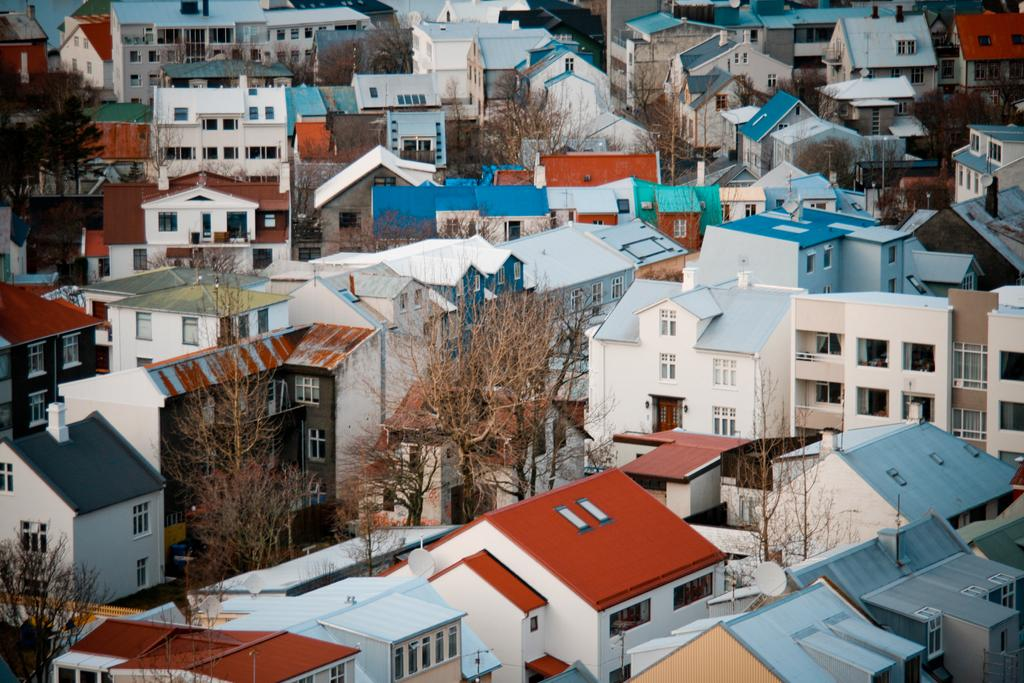Where was the picture taken? The picture was clicked outside the city. What can be seen in the image besides the buildings? There are many trees in the image. What colors are the roofs of the buildings in the image? The roofs of the buildings have different colors: blue, red, and grey. What type of afterthought is depicted in the image? There is no afterthought depicted in the image; it features trees, buildings, and colored roofs. 